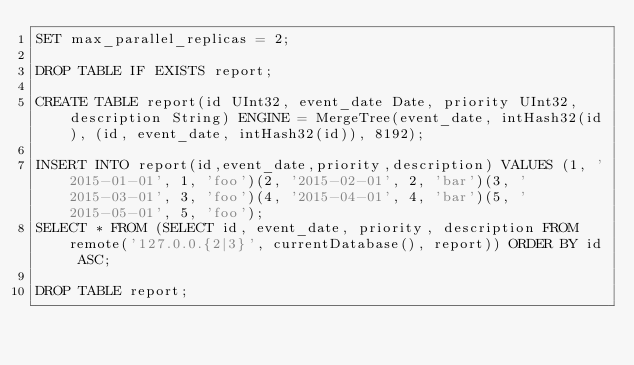Convert code to text. <code><loc_0><loc_0><loc_500><loc_500><_SQL_>SET max_parallel_replicas = 2;

DROP TABLE IF EXISTS report;

CREATE TABLE report(id UInt32, event_date Date, priority UInt32, description String) ENGINE = MergeTree(event_date, intHash32(id), (id, event_date, intHash32(id)), 8192);

INSERT INTO report(id,event_date,priority,description) VALUES (1, '2015-01-01', 1, 'foo')(2, '2015-02-01', 2, 'bar')(3, '2015-03-01', 3, 'foo')(4, '2015-04-01', 4, 'bar')(5, '2015-05-01', 5, 'foo');
SELECT * FROM (SELECT id, event_date, priority, description FROM remote('127.0.0.{2|3}', currentDatabase(), report)) ORDER BY id ASC;

DROP TABLE report;
</code> 